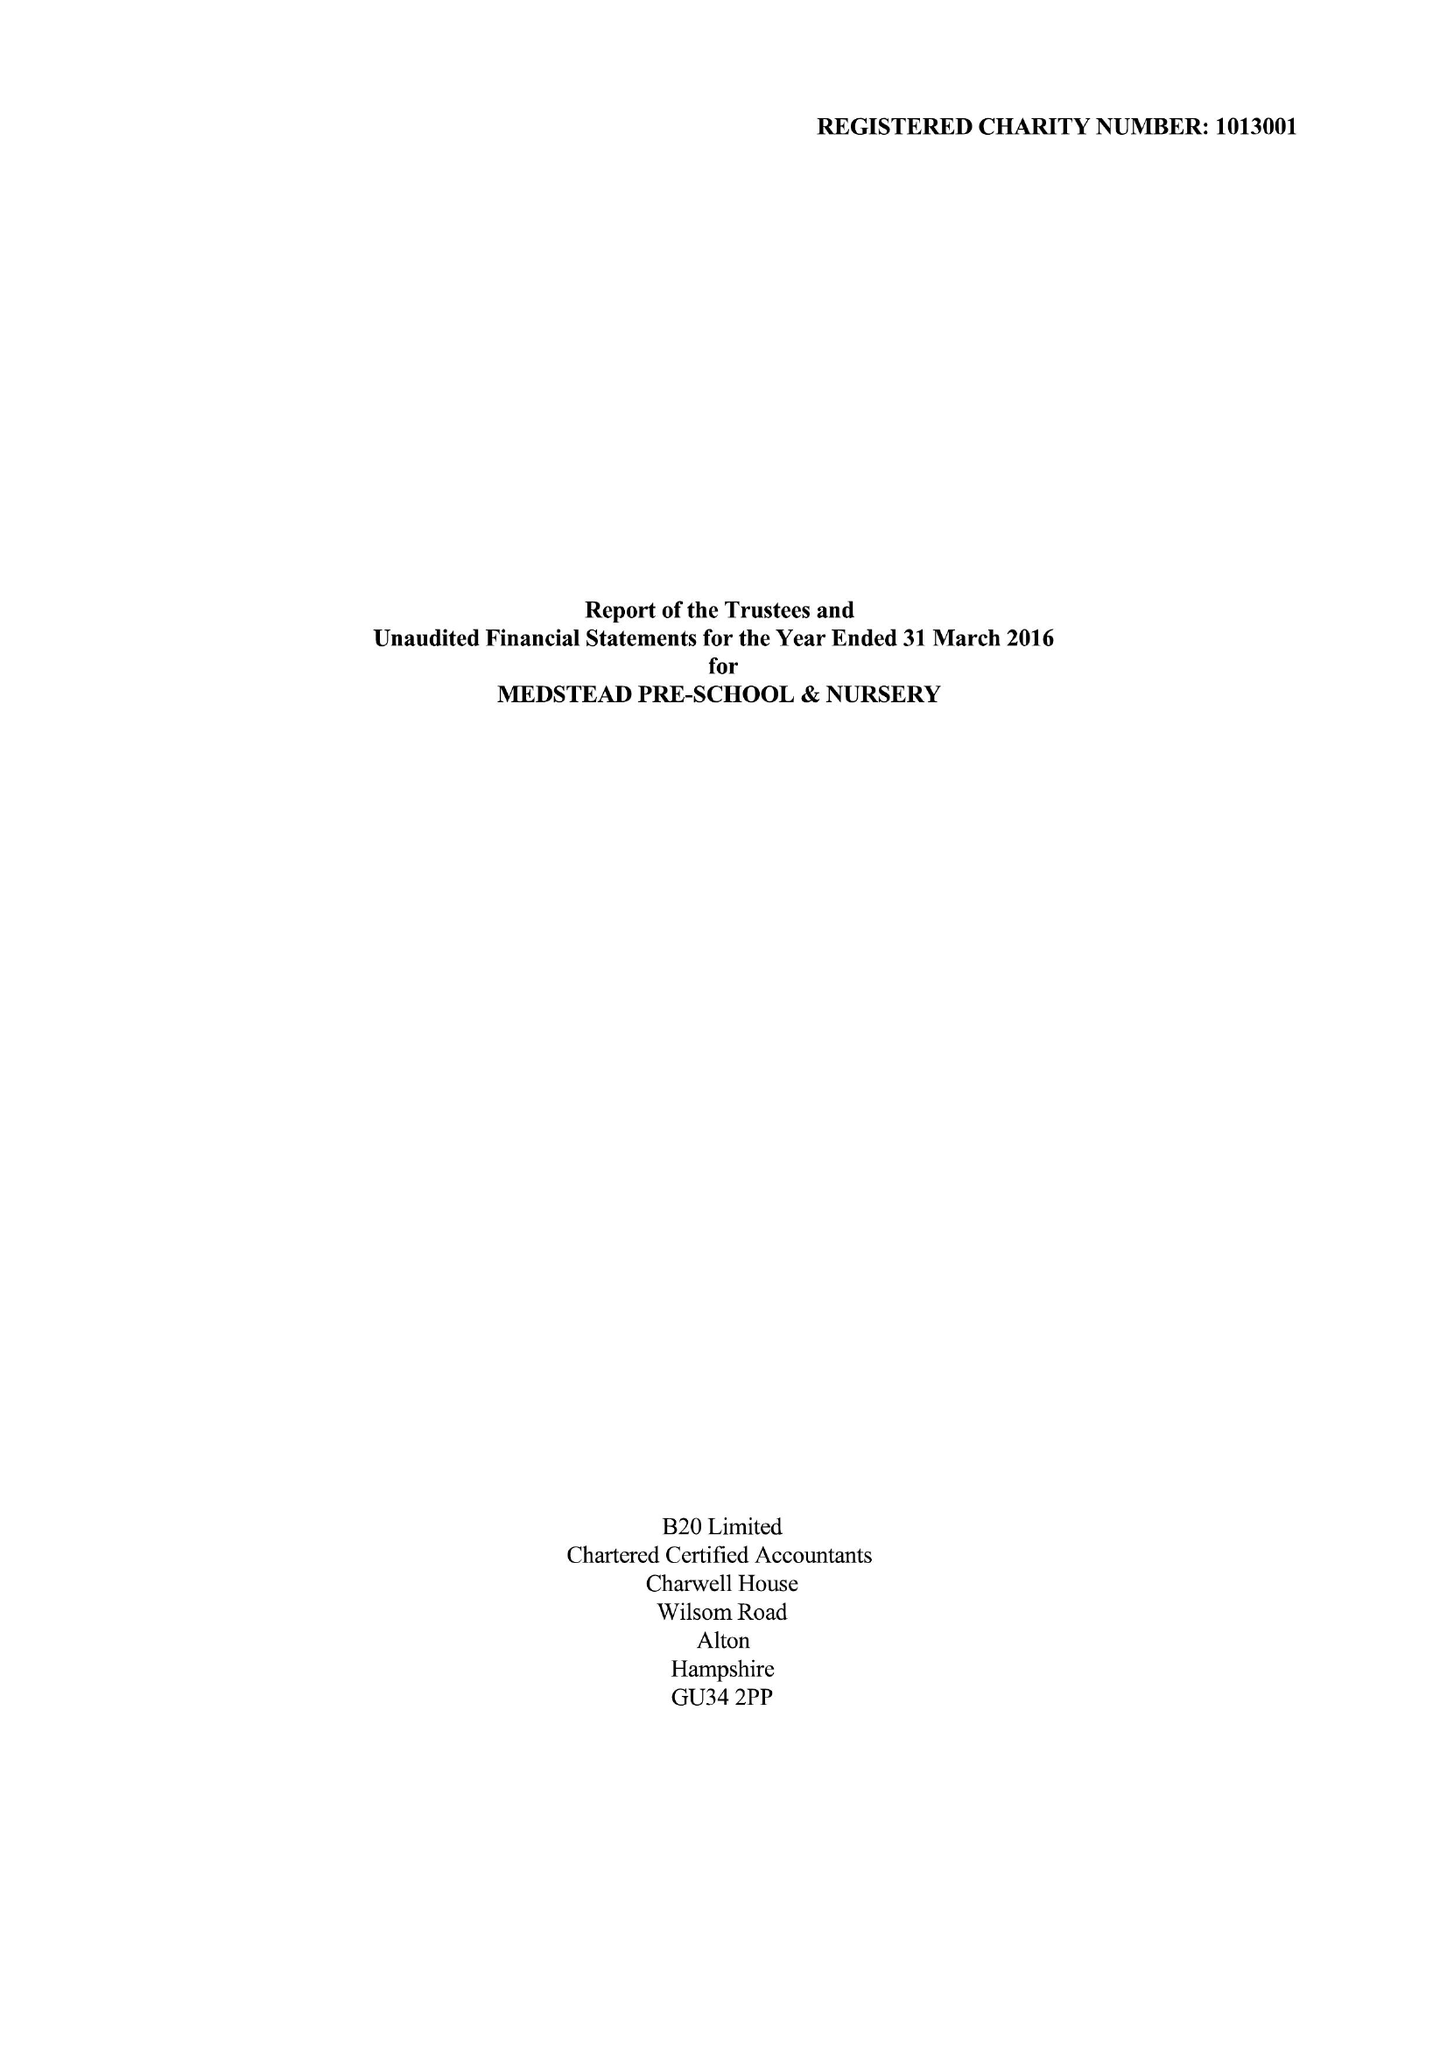What is the value for the income_annually_in_british_pounds?
Answer the question using a single word or phrase. 155544.00 